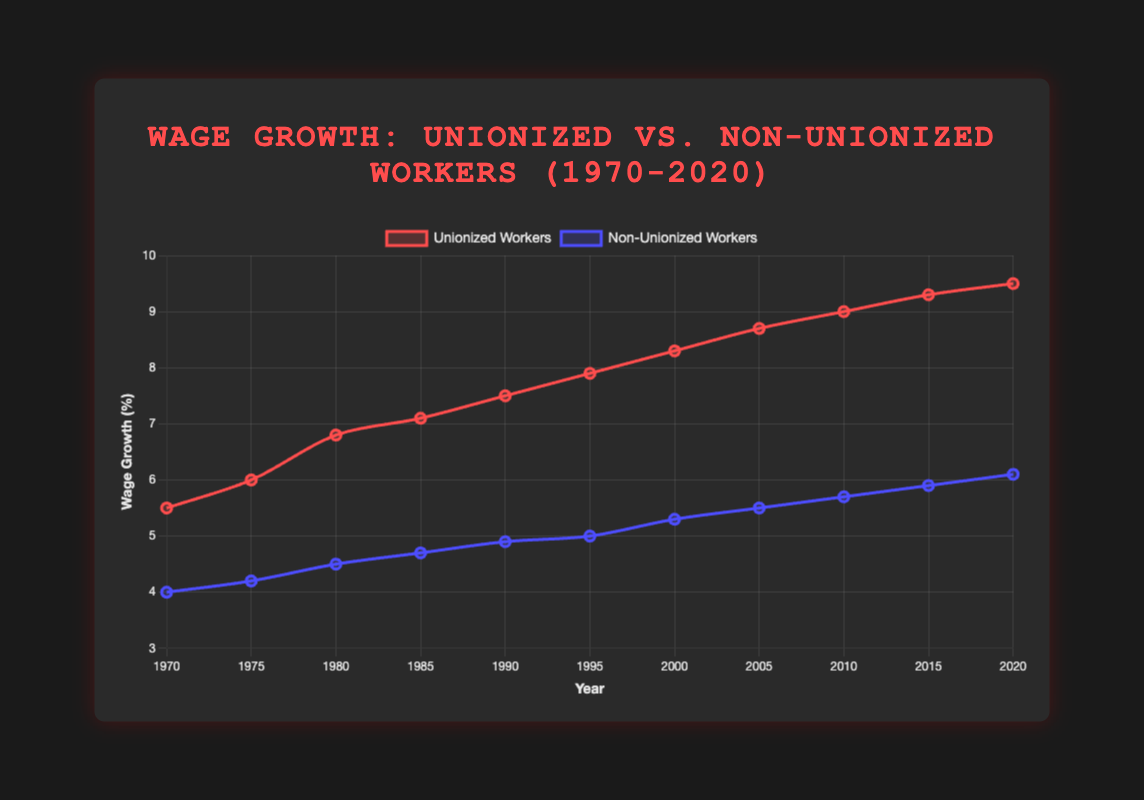What is the overall trend of wage growth for unionized workers from 1970 to 2020? The figure shows an upward trend in wage growth for unionized workers, starting at 5.5% in 1970 and reaching 9.5% in 2020. This indicates continuous growth over the 50-year period.
Answer: Upward trend How does the wage growth in 1970 compare between unionized and non-unionized workers? In 1970, unionized workers had a wage growth of 5.5% while non-unionized workers had a wage growth of 4.0%. The wage growth for unionized workers was higher by 1.5%.
Answer: Unionized workers had higher wage growth by 1.5% In which year was the difference between unionized and non-unionized wage growth the smallest? To find the smallest difference, we look at the gaps for each year. The smallest difference is in 1975, where unionized wage growth was 6.0% and non-unionized was 4.2%, giving a difference of 1.8%.
Answer: 1975 What is the average wage growth for non-unionized workers over the 50-year period? Summing the wage growth for non-unionized workers (4.0 + 4.2 + 4.5 + 4.7 + 4.9 + 5.0 + 5.3 + 5.5 + 5.7 + 5.9 + 6.1) equals 55.8. Dividing by 11 years gives an average of 55.8 / 11 = 5.073%.
Answer: 5.073% What visual differences can you identify between the lines representing unionized and non-unionized workers? The line representing unionized workers is red and has larger, more pronounced data points compared to the blue line representing non-unionized workers. The unionized line generally stays above the non-unionized line.
Answer: Red line for unionized, blue line for non-unionized Between 1985 and 1995, which group saw a larger increase in wage growth? For unionized workers, wage growth increased from 7.1% in 1985 to 7.9% in 1995, an increase of 0.8%. For non-unionized workers, it increased from 4.7% in 1985 to 5.0% in 1995, an increase of 0.3%. The unionized group saw a larger increase.
Answer: Unionized workers What is the compounded percentage increase in wage growth for unionized workers from 1970 to 2020? The percentage increase from initial value 5.5% to final value 9.5% can be calculated as ((9.5 - 5.5) / 5.5) * 100%. This yields a (4 / 5.5) * 100% = 72.73%.
Answer: 72.73% By how much did the wage growth for non-unionized workers change between 2010 and 2020? In 2010, the wage growth for non-unionized workers was 5.7%. By 2020, it was 6.1%. The change is calculated as 6.1 - 5.7 = 0.4%.
Answer: 0.4% Is there any year where the wage growth of non-unionized workers surpassed that of unionized workers? Reviewing the data points provided, there is no year where the wage growth for non-unionized workers surpassed that of unionized workers.
Answer: No Which group exhibited more consistent growth from 1970 to 2020, judging by the smoothness of their respective lines? The lines' smoothness suggests consistent growth. Both lines appear relatively smooth, but the blue line (non-unionized workers) appears slightly more consistent without significant jumps or drops.
Answer: Non-unionized workers 